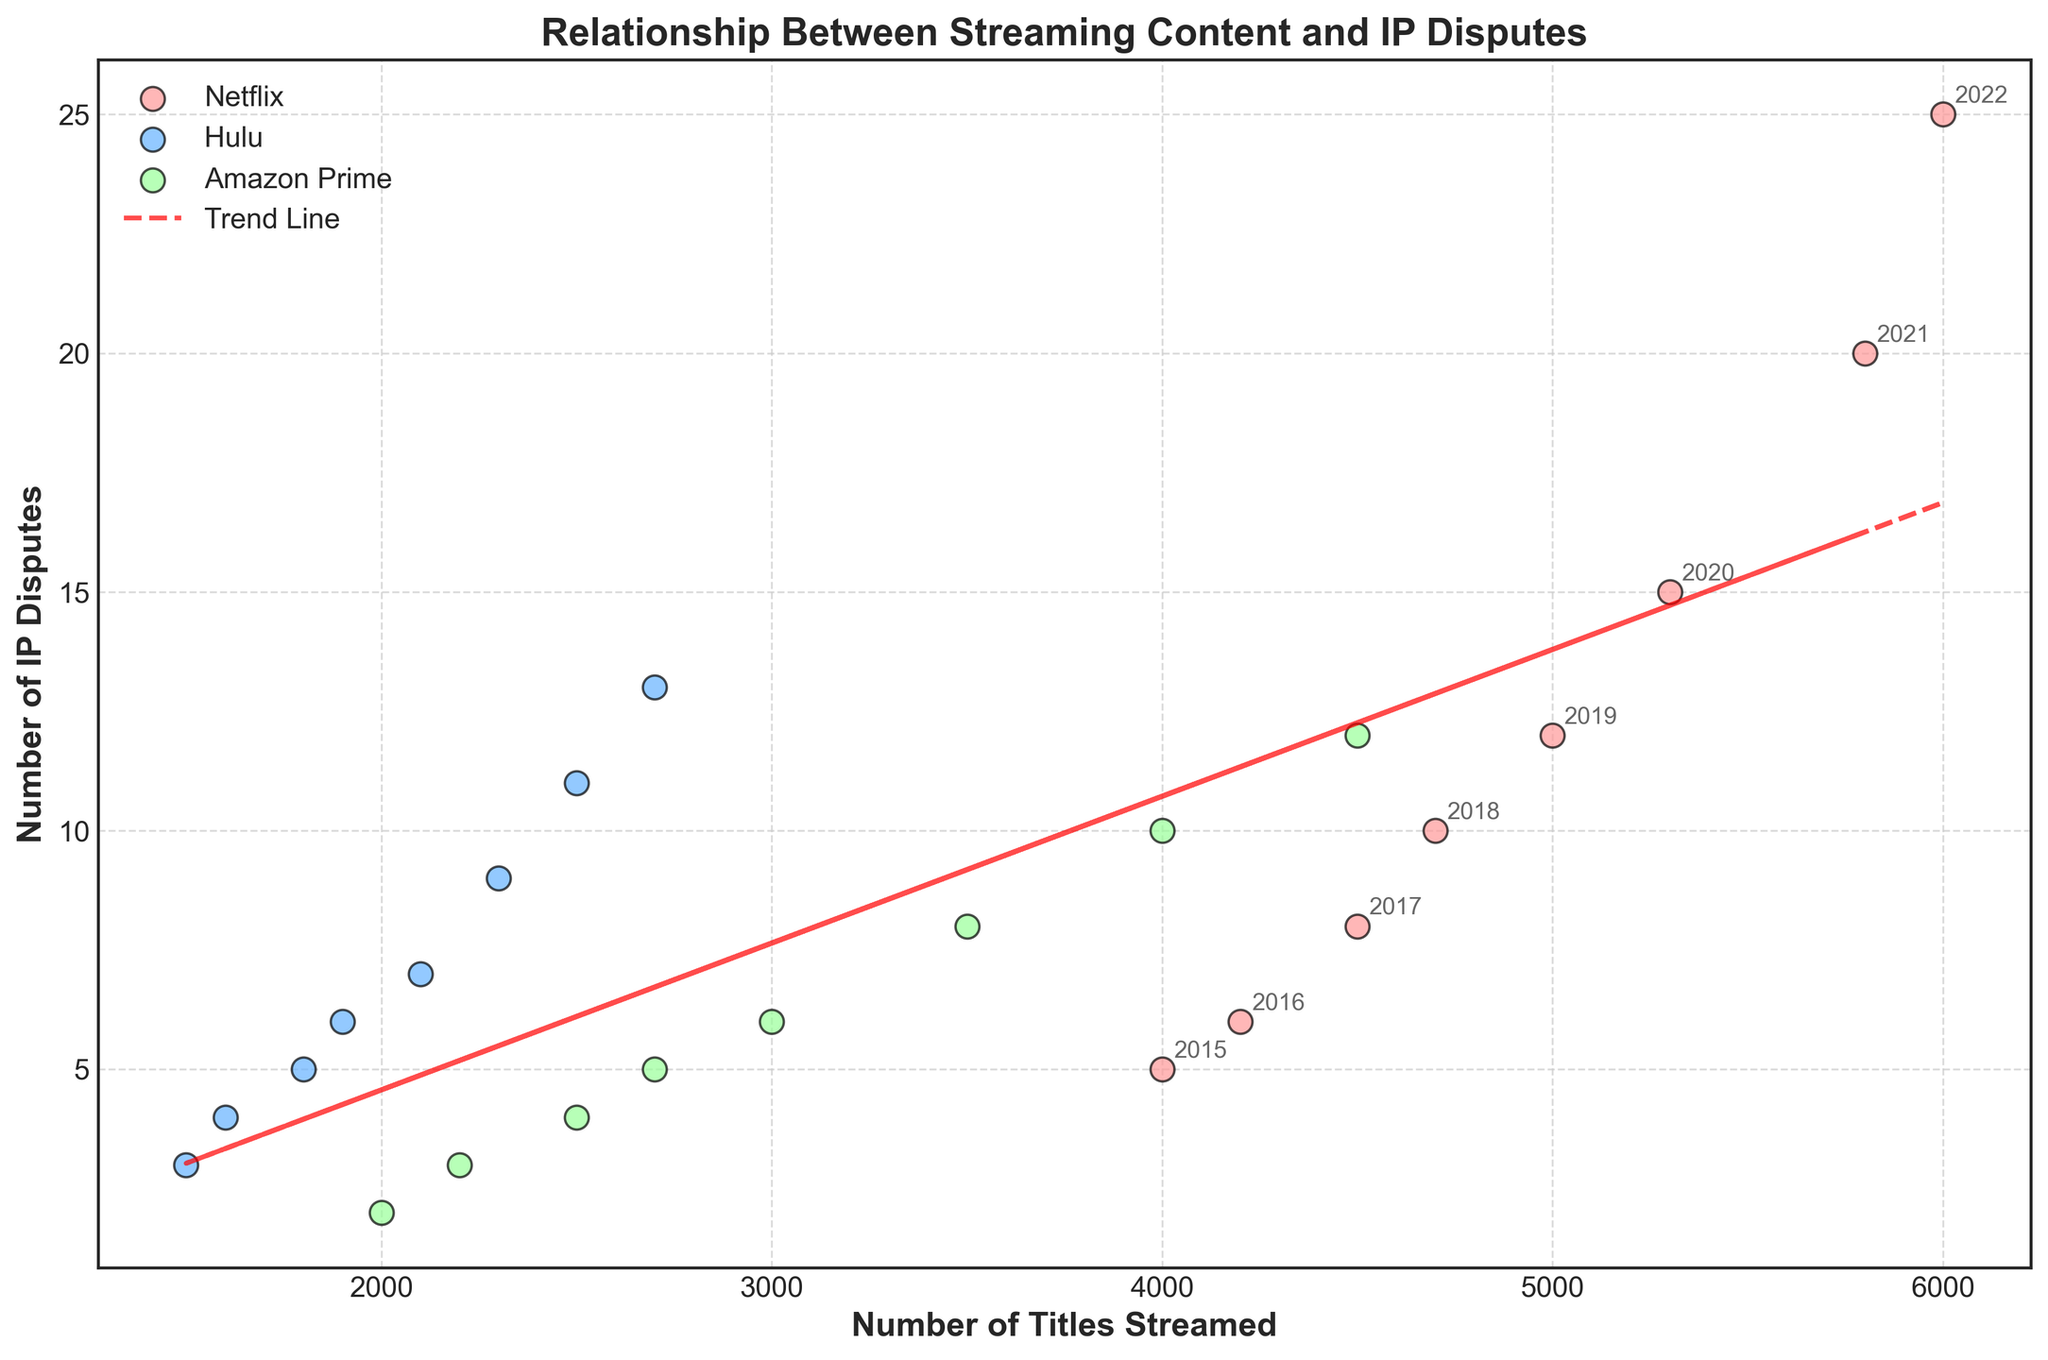What is the title of the plot? The title is displayed at the top of the figure. It is written in bold and clearly summarizes what the plot is about.
Answer: Relationship Between Streaming Content and IP Disputes What are the labels for the x-axis and y-axis? The x-axis and y-axis labels are written in bold and located along the axes. The x-axis label is below the horizontal axis, and the y-axis label is to the left of the vertical axis.
Answer: Number of Titles Streamed (x-axis), Number of IP Disputes (y-axis) Which streaming service has the highest number of IP disputes in the latest year shown? By observing the scatter points and their annotations, we can determine the data for the most recent year (2022). The service with the highest y-value in 2022 indicates the most IP disputes.
Answer: Netflix How does the trend line depict the general relationship between the number of titles streamed and the number of IP disputes? The trend line shows the general direction and slope of the relationship between the two variables. If it slopes upwards from left to right, it suggests a positive correlation.
Answer: Positive correlation What is the color used to represent Hulu's data points? The color scheme for each streaming service's data points can be noted by looking at the legend. The specific color corresponding to Hulu is shown in the legend.
Answer: Blue Which year shows the largest increase in the number of IP disputes for Netflix? By examining the annotations and plotting them year by year, we can observe the change in the IP disputes over time for Netflix. Identifying the year with the largest difference in y-values gives the answer.
Answer: 2021 Comparing Netflix and Hulu, which service streamed more titles in 2020? The scatter points annotated with the year 2020 for both services need to be compared in terms of their x-values. The larger x-value indicates more titles streamed.
Answer: Netflix On average, how many titles were streamed in 2018 across all streaming services? To determine the average, sum the x-values (titles streamed) for all three services in 2018 and divide by the number of services. (4700 + 1900 + 2700) / 3 = 3100
Answer: 3100 What is the trend in the number of IP disputes for Amazon Prime from 2015 to 2022? Checking the y-values for Amazon Prime year by year will indicate whether there is an upward or downward trend. A consistent increase or decrease will confirm the trend direction.
Answer: Upward trend Do Hulu’s data points show a stronger correlation with the number of titles streamed and IP disputes compared to Amazon Prime? Comparing the spread of scatter points around the trend line for Hulu and Amazon Prime will indicate the strength of the correlation. Tighter clustering indicates a stronger correlation.
Answer: Hulu shows a stronger correlation 